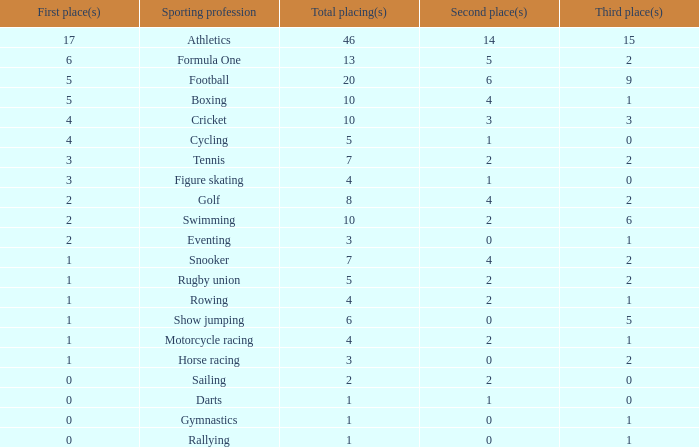How many second place showings does snooker have? 4.0. Could you parse the entire table? {'header': ['First place(s)', 'Sporting profession', 'Total placing(s)', 'Second place(s)', 'Third place(s)'], 'rows': [['17', 'Athletics', '46', '14', '15'], ['6', 'Formula One', '13', '5', '2'], ['5', 'Football', '20', '6', '9'], ['5', 'Boxing', '10', '4', '1'], ['4', 'Cricket', '10', '3', '3'], ['4', 'Cycling', '5', '1', '0'], ['3', 'Tennis', '7', '2', '2'], ['3', 'Figure skating', '4', '1', '0'], ['2', 'Golf', '8', '4', '2'], ['2', 'Swimming', '10', '2', '6'], ['2', 'Eventing', '3', '0', '1'], ['1', 'Snooker', '7', '4', '2'], ['1', 'Rugby union', '5', '2', '2'], ['1', 'Rowing', '4', '2', '1'], ['1', 'Show jumping', '6', '0', '5'], ['1', 'Motorcycle racing', '4', '2', '1'], ['1', 'Horse racing', '3', '0', '2'], ['0', 'Sailing', '2', '2', '0'], ['0', 'Darts', '1', '1', '0'], ['0', 'Gymnastics', '1', '0', '1'], ['0', 'Rallying', '1', '0', '1']]} 